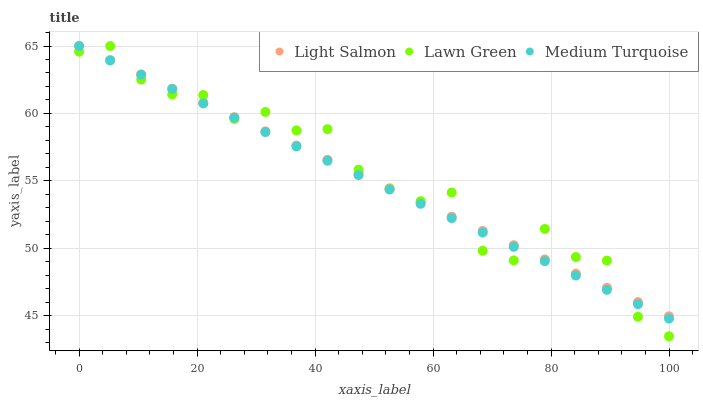Does Medium Turquoise have the minimum area under the curve?
Answer yes or no. Yes. Does Lawn Green have the maximum area under the curve?
Answer yes or no. Yes. Does Light Salmon have the minimum area under the curve?
Answer yes or no. No. Does Light Salmon have the maximum area under the curve?
Answer yes or no. No. Is Light Salmon the smoothest?
Answer yes or no. Yes. Is Lawn Green the roughest?
Answer yes or no. Yes. Is Medium Turquoise the smoothest?
Answer yes or no. No. Is Medium Turquoise the roughest?
Answer yes or no. No. Does Lawn Green have the lowest value?
Answer yes or no. Yes. Does Medium Turquoise have the lowest value?
Answer yes or no. No. Does Medium Turquoise have the highest value?
Answer yes or no. Yes. Does Medium Turquoise intersect Lawn Green?
Answer yes or no. Yes. Is Medium Turquoise less than Lawn Green?
Answer yes or no. No. Is Medium Turquoise greater than Lawn Green?
Answer yes or no. No. 